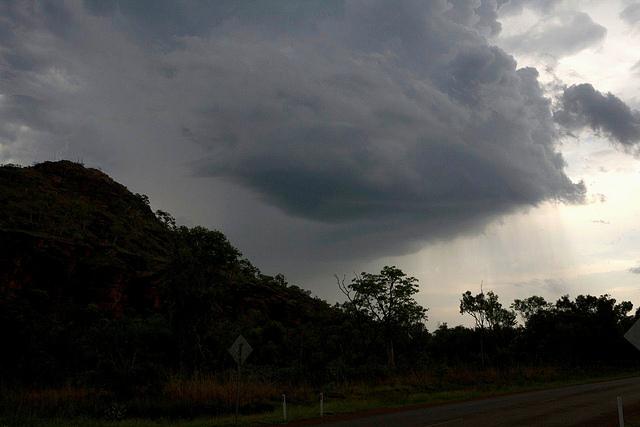Is it about to rain?
Write a very short answer. Yes. Is it winter?
Answer briefly. No. Where is this picture taken?
Answer briefly. Outside. Is it sunny or rainy?
Short answer required. Rainy. What type of weather is featured in the picture?
Answer briefly. Cloudy. Is the sun out?
Short answer required. No. What color are the clouds?
Be succinct. Gray. Where is the fire hydrant?
Keep it brief. Nowhere. How many people can be seen?
Write a very short answer. 0. What is soaring in the sky?
Answer briefly. Clouds. Where are the mountains?
Concise answer only. Hawaii. Does this look like a heavy storm?
Concise answer only. Yes. Is it stormy?
Short answer required. Yes. Is there a prairie landscape?
Write a very short answer. No. What's the weather like in this photo?
Keep it brief. Cloudy. Does the weather look nice?
Quick response, please. No. What time of day is it?
Be succinct. Evening. How is the sky?
Give a very brief answer. Cloudy. Is the total sum of birds in the sky divisible by zero?
Be succinct. No. Is it raining in this picture?
Keep it brief. Yes. Where is this?
Quick response, please. Outside. What season is it?
Answer briefly. Summer. Is it a nice day?
Keep it brief. No. What is the main color of the sky?
Be succinct. Gray. What does the road sign mean?
Write a very short answer. Yield. Is that a bird or just a hole in the sky?
Quick response, please. Hole. What color is the sky?
Quick response, please. Gray. Is it raining in this photo?
Quick response, please. No. Is it sunny?
Keep it brief. No. Is it a rainy day?
Keep it brief. Yes. Is that an angry truck?
Short answer required. No. Is it a sunny or rainy day in the photo?
Concise answer only. Rainy. Is the sky clear?
Give a very brief answer. No. Why are there clouds?
Write a very short answer. Storm. Can the signs be read?
Quick response, please. No. 